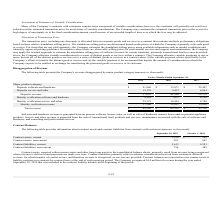From Mitek Systems's financial document, What are the balances of current contract assets and liabilities as of September 30, 2019, respectively? The document shows two values: $2,350 and 5,612 (in thousands). From the document: "Contract liabilities, current 5,612 4,281 Contract assets, current $ 2,350 $ 169..." Also, What do contract liabilities primarily relate to? advance consideration received from customers, deferred revenue, for which transfer of control occurs, and therefore revenue is recognized, as services are provided. The document states: "er time. Contract liabilities primarily relate to advance consideration received from customers, deferred revenue, for which transfer of control occur..." Also, How are contract balances being reported? in a net contract asset or liability position on a contract-by-contract basis at the end of each reporting period. The document states: "ices are provided. Contract balances are reported in a net contract asset or liability position on a contract-by-contract basis at the end of each rep..." Also, can you calculate: What is the percentage change of total balances of contract assets, including current and non-current, from 2018 to 2019? To answer this question, I need to perform calculations using the financial data. The calculation is: ((2,350+581)-(169+507))/(169+507) , which equals 333.58 (percentage). This is based on the information: "Contract assets, non-current 581 507 Contract assets, current $ 2,350 $ 169 Contract assets, non-current 581 507 Contract assets, current $ 2,350 $ 169..." The key data points involved are: 169, 2,350, 507. Also, can you calculate: What is the total balance of contract assets and liabilities in 2019? Based on the calculation: 2,350+581+5,612+736 , the result is 9279 (in thousands). This is based on the information: "Contract liabilities, current 5,612 4,281 Contract assets, non-current 581 507 Contract assets, current $ 2,350 $ 169 Contract liabilities, non-current 736 485..." The key data points involved are: 2,350, 5,612, 581. Also, can you calculate: What is the ratio of contract liabilities to contract assets in 2018? To answer this question, I need to perform calculations using the financial data. The calculation is: (4,281+485)/(169+507) , which equals 7.05. This is based on the information: "Contract assets, non-current 581 507 Contract assets, current $ 2,350 $ 169 Contract liabilities, current 5,612 4,281 Contract liabilities, non-current 736 485..." The key data points involved are: 169, 4,281, 485. 